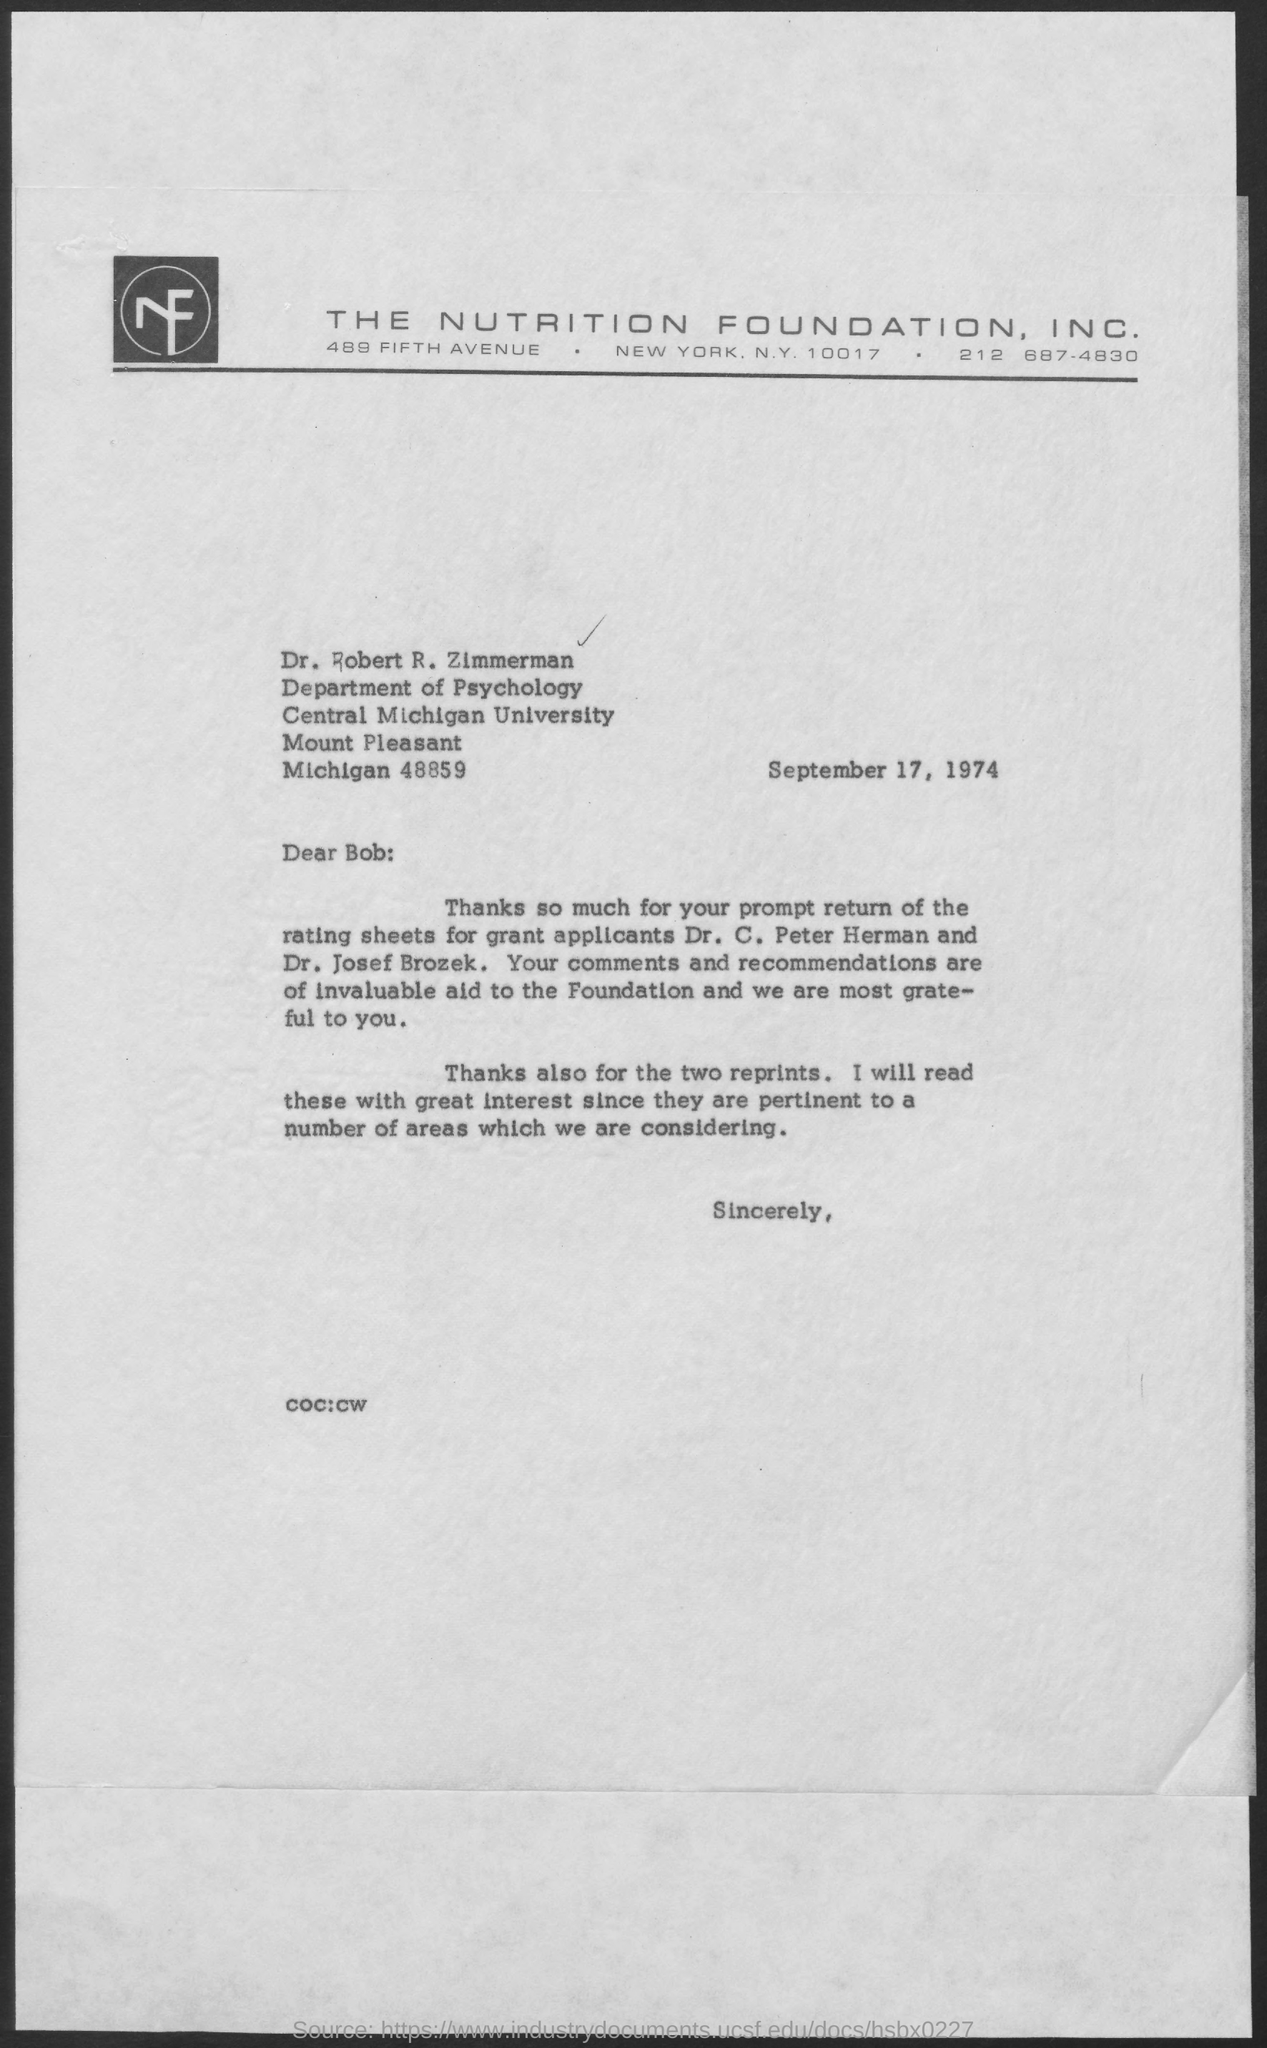Draw attention to some important aspects in this diagram. This letter is addressed to Dr. Robert R. Zimmerman. 